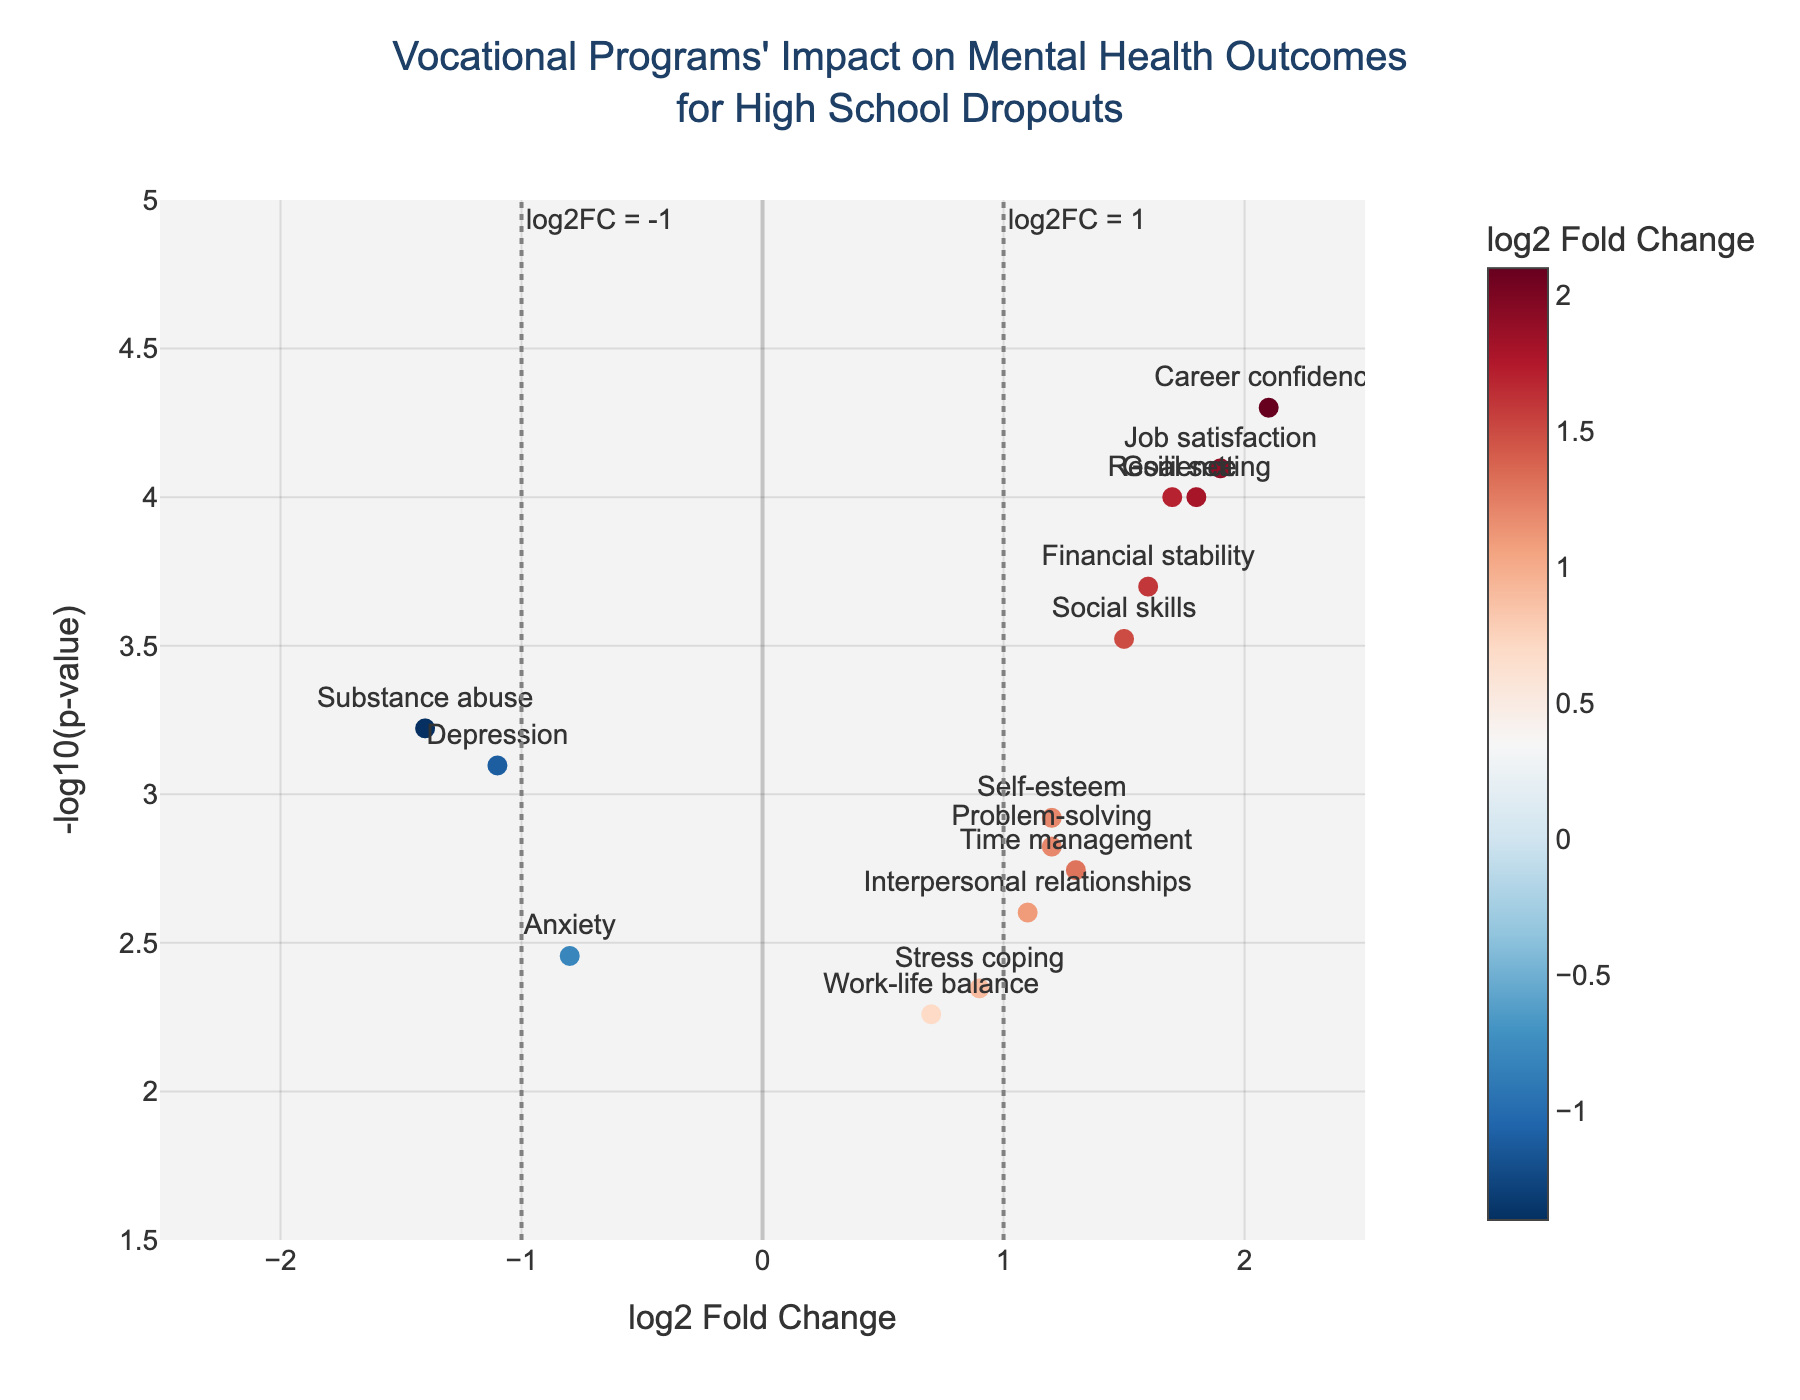What is the title of the figure? The title is displayed at the top of the plot.
Answer: Vocational Programs' Impact on Mental Health Outcomes for High School Dropouts What are the x-axis and y-axis labels? The labels are visible along the respective axes. The x-axis label is "log2 Fold Change" and the y-axis label is "-log10(p-value)".
Answer: log2 Fold Change; -log10(p-value) How many data points have a positive log2 Fold Change greater than 1? To find this, count the data points with log2 Fold Change values greater than 1.
Answer: 8 Which mental health outcome has the highest -log10(p-value)? Locate the highest point on the y-axis to determine the corresponding mental health outcome.
Answer: Career confidence Which mental health outcome shows the greatest improvement in vocational program completers? Improvement can be identified by the highest positive log2 Fold Change value.
Answer: Career confidence Which outcome has the smallest p-value, and what is its log2 Fold Change? Find the data point with the lowest p-value, then identify its log2 Fold Change.
Answer: Career confidence; 2.1 How many mental health outcomes have a significant p-value threshold of less than 0.05? Count the data points below the horizontal line indicating a p-value threshold of 0.05 (or -log10(p-value) > 1.3).
Answer: 15 Which two mental health outcomes have the largest negative log2 Fold Changes? Identify the two lowest values for log2 Fold Change.
Answer: Substance abuse and Depression How does the p-value of 'Self-esteem' compare to that of 'Stress coping'? Compare the -log10(p-value) values for both outcomes on the y-axis.
Answer: Self-esteem's p-value is lower than Stress coping's p-value What can be said about the outcome 'Substance abuse' in terms of p-value and log2 Fold Change? Locate the point for Substance abuse to determine its p-value and log2 Fold Change.
Answer: It has a p-value of 0.0006 and a log2 Fold Change of -1.4 